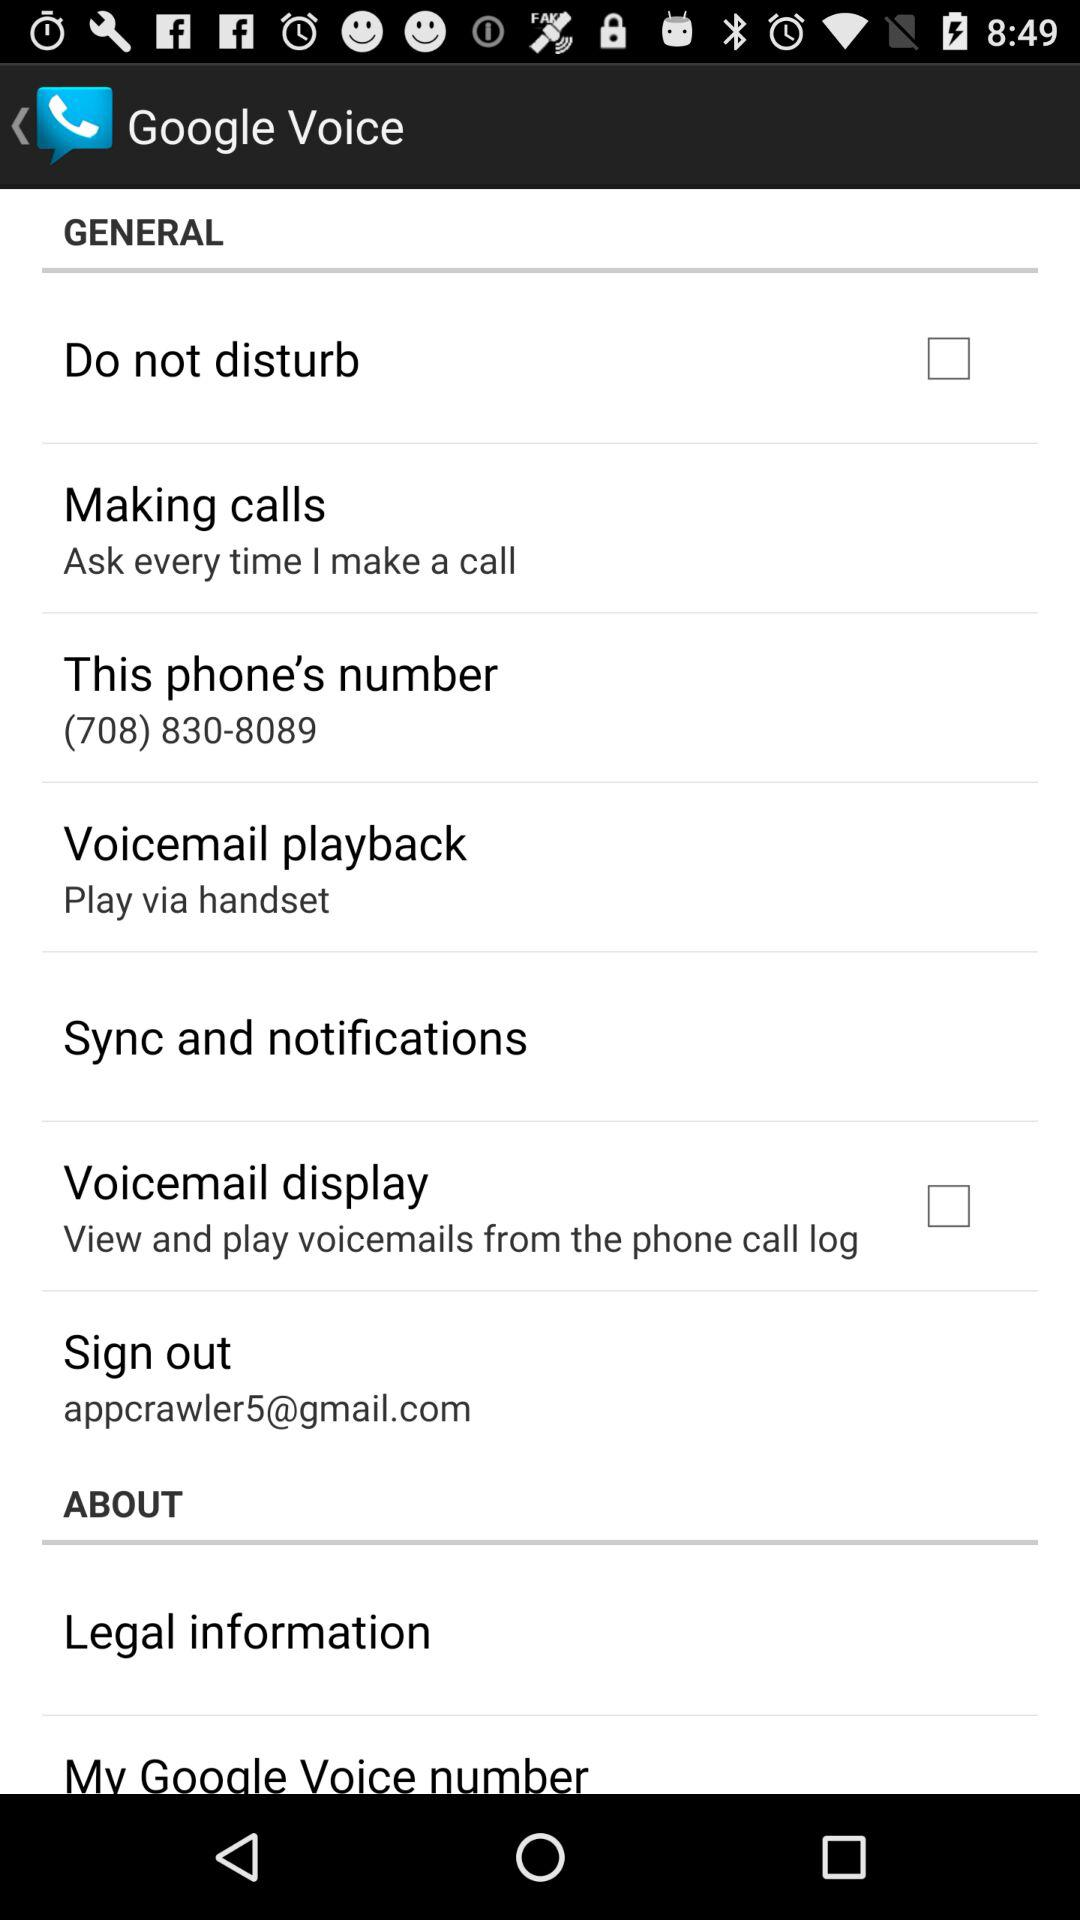What is the phone number? The phone number is (708) 830-8089. 